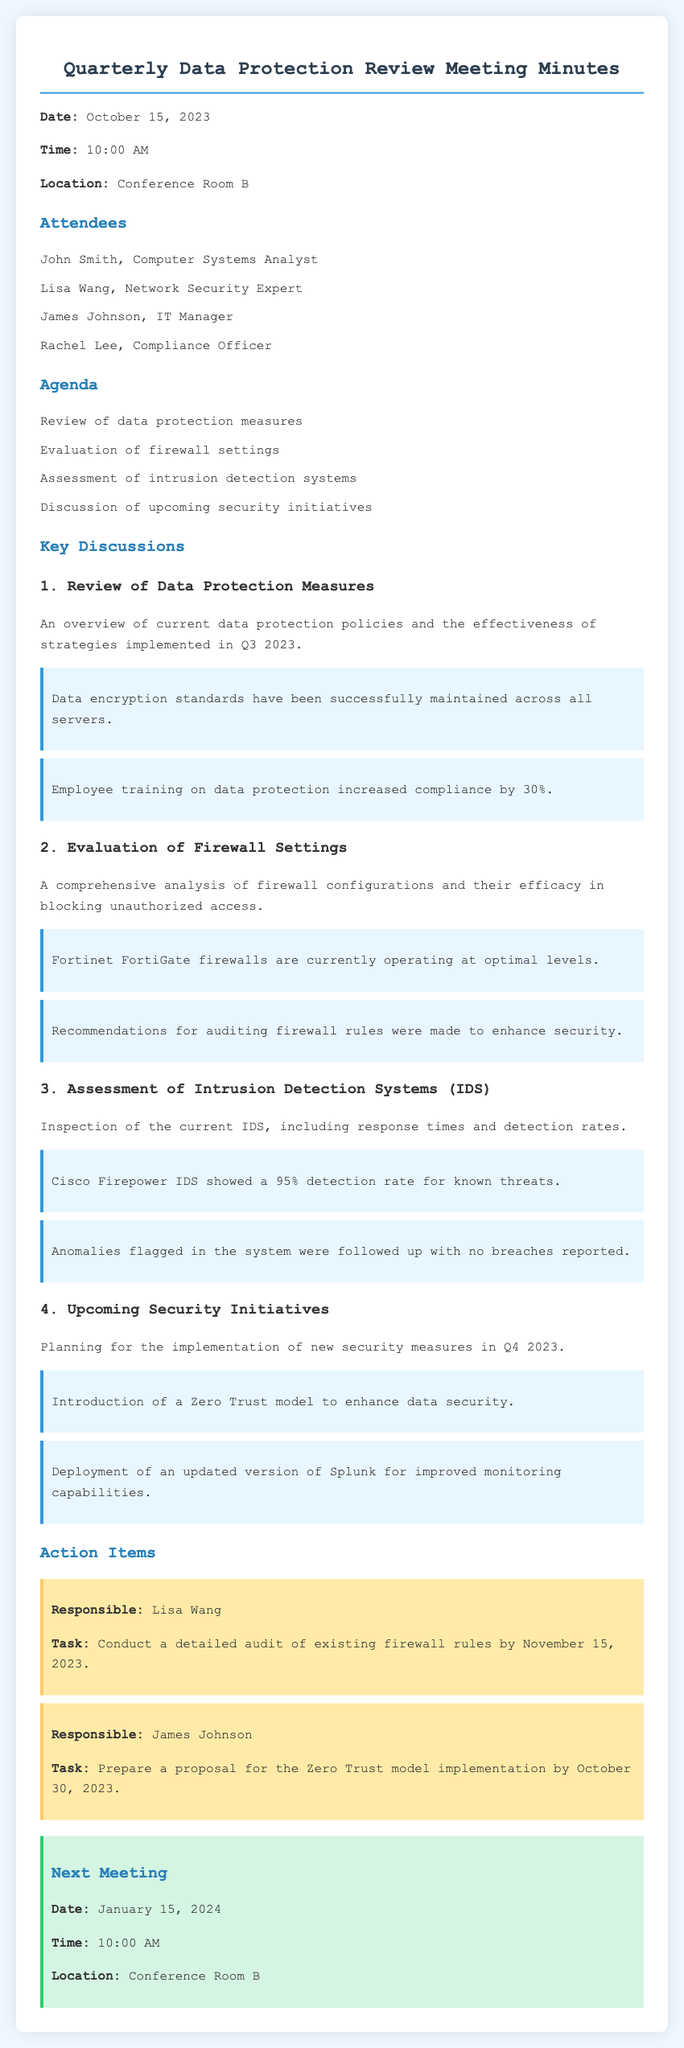What is the date of the meeting? The date of the meeting is clearly stated in the document.
Answer: October 15, 2023 Who is the Network Security Expert in attendance? The document lists all attendees, including their roles.
Answer: Lisa Wang What is the main purpose of evaluating firewall settings? The document outlines the agenda, specifying the evaluation's purpose.
Answer: Blocking unauthorized access What detection rate does the Cisco Firepower IDS achieve? The specific performance of the IDS is mentioned in the key discussions.
Answer: 95% What is the deadline for the firewall rules audit? The action items section specifies the deadline for the task.
Answer: November 15, 2023 What security model will be introduced in Q4 2023? The document discusses the upcoming security initiatives including models.
Answer: Zero Trust model How much did employee training increase compliance by? The document includes information about the impact of training on compliance.
Answer: 30% When is the next meeting scheduled? The next meeting's details are provided in the document.
Answer: January 15, 2024 